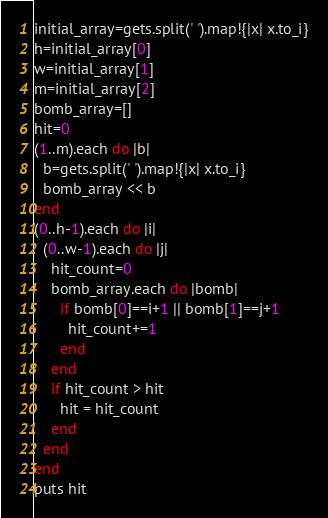Convert code to text. <code><loc_0><loc_0><loc_500><loc_500><_Ruby_>initial_array=gets.split(' ').map!{|x| x.to_i}
h=initial_array[0]
w=initial_array[1]
m=initial_array[2]
bomb_array=[]
hit=0
(1..m).each do |b|
  b=gets.split(' ').map!{|x| x.to_i}
  bomb_array << b
end
(0..h-1).each do |i|
  (0..w-1).each do |j|
    hit_count=0
    bomb_array.each do |bomb|
      if bomb[0]==i+1 || bomb[1]==j+1
        hit_count+=1
      end
    end
    if hit_count > hit
      hit = hit_count
    end
  end
end
puts hit</code> 